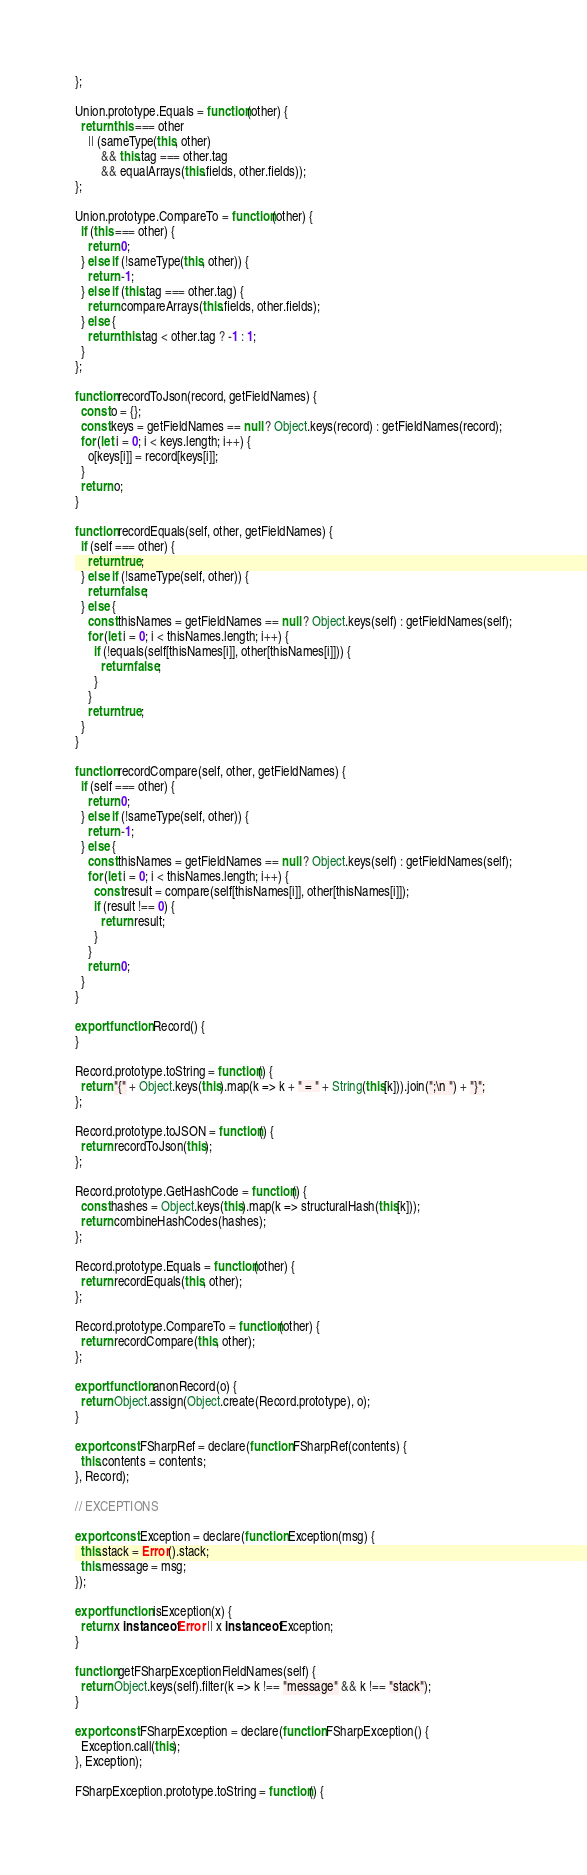<code> <loc_0><loc_0><loc_500><loc_500><_JavaScript_>};

Union.prototype.Equals = function(other) {
  return this === other
    || (sameType(this, other)
        && this.tag === other.tag
        && equalArrays(this.fields, other.fields));
};

Union.prototype.CompareTo = function(other) {
  if (this === other) {
    return 0;
  } else if (!sameType(this, other)) {
    return -1;
  } else if (this.tag === other.tag) {
    return compareArrays(this.fields, other.fields);
  } else {
    return this.tag < other.tag ? -1 : 1;
  }
};

function recordToJson(record, getFieldNames) {
  const o = {};
  const keys = getFieldNames == null ? Object.keys(record) : getFieldNames(record);
  for (let i = 0; i < keys.length; i++) {
    o[keys[i]] = record[keys[i]];
  }
  return o;
}

function recordEquals(self, other, getFieldNames) {
  if (self === other) {
    return true;
  } else if (!sameType(self, other)) {
    return false;
  } else {
    const thisNames = getFieldNames == null ? Object.keys(self) : getFieldNames(self);
    for (let i = 0; i < thisNames.length; i++) {
      if (!equals(self[thisNames[i]], other[thisNames[i]])) {
        return false;
      }
    }
    return true;
  }
}

function recordCompare(self, other, getFieldNames) {
  if (self === other) {
    return 0;
  } else if (!sameType(self, other)) {
    return -1;
  } else {
    const thisNames = getFieldNames == null ? Object.keys(self) : getFieldNames(self);
    for (let i = 0; i < thisNames.length; i++) {
      const result = compare(self[thisNames[i]], other[thisNames[i]]);
      if (result !== 0) {
        return result;
      }
    }
    return 0;
  }
}

export function Record() {
}

Record.prototype.toString = function() {
  return "{" + Object.keys(this).map(k => k + " = " + String(this[k])).join(";\n ") + "}";
};

Record.prototype.toJSON = function() {
  return recordToJson(this);
};

Record.prototype.GetHashCode = function() {
  const hashes = Object.keys(this).map(k => structuralHash(this[k]));
  return combineHashCodes(hashes);
};

Record.prototype.Equals = function(other) {
  return recordEquals(this, other);
};

Record.prototype.CompareTo = function(other) {
  return recordCompare(this, other);
};

export function anonRecord(o) {
  return Object.assign(Object.create(Record.prototype), o);
}

export const FSharpRef = declare(function FSharpRef(contents) {
  this.contents = contents;
}, Record);

// EXCEPTIONS

export const Exception = declare(function Exception(msg) {
  this.stack = Error().stack;
  this.message = msg;
});

export function isException(x) {
  return x instanceof Error || x instanceof Exception;
}

function getFSharpExceptionFieldNames(self) {
  return Object.keys(self).filter(k => k !== "message" && k !== "stack");
}

export const FSharpException = declare(function FSharpException() {
  Exception.call(this);
}, Exception);

FSharpException.prototype.toString = function() {</code> 